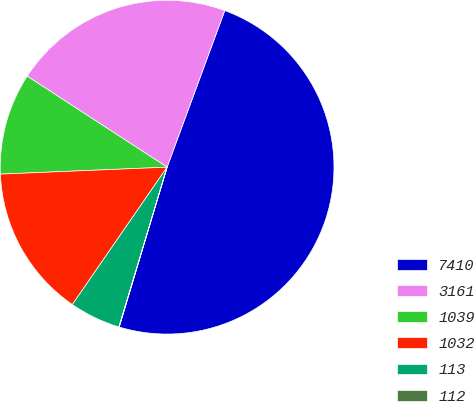<chart> <loc_0><loc_0><loc_500><loc_500><pie_chart><fcel>7410<fcel>3161<fcel>1039<fcel>1032<fcel>113<fcel>112<nl><fcel>49.01%<fcel>21.44%<fcel>9.84%<fcel>14.73%<fcel>4.94%<fcel>0.04%<nl></chart> 